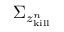<formula> <loc_0><loc_0><loc_500><loc_500>\Sigma _ { z _ { k i l l } ^ { n } }</formula> 